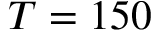<formula> <loc_0><loc_0><loc_500><loc_500>T = 1 5 0</formula> 